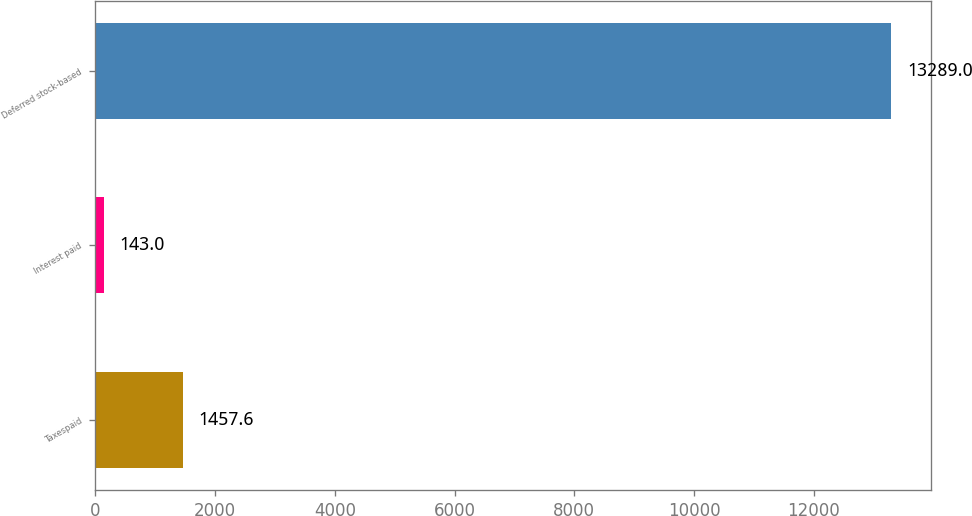Convert chart to OTSL. <chart><loc_0><loc_0><loc_500><loc_500><bar_chart><fcel>Taxespaid<fcel>Interest paid<fcel>Deferred stock-based<nl><fcel>1457.6<fcel>143<fcel>13289<nl></chart> 